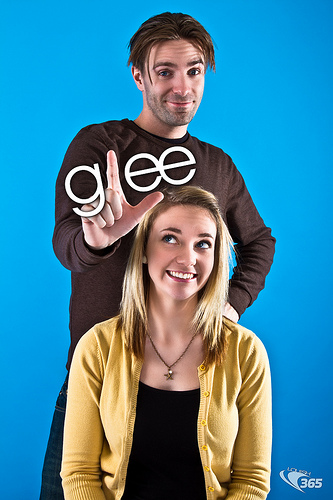<image>
Is the man above the girl? Yes. The man is positioned above the girl in the vertical space, higher up in the scene. 